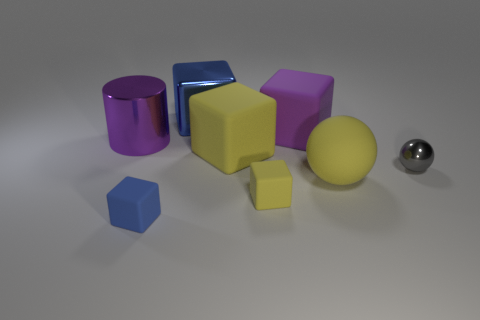What are the shapes and colors of the objects in the image? The image contains a variety of geometric shapes in different colors. There's a shiny matte sphere on the right, a purple cylinder, and two cubes—one purple and one yellow—along with a smaller yellow cube. There's also a blue rectangular prism lying down, and a small blue cube in the foreground. 